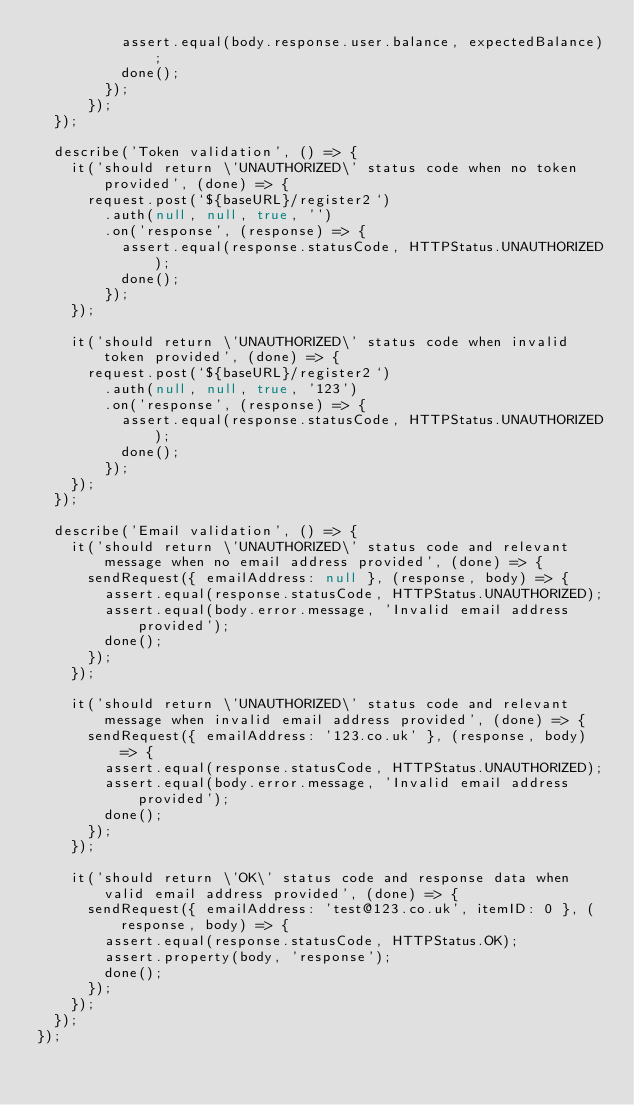<code> <loc_0><loc_0><loc_500><loc_500><_TypeScript_>          assert.equal(body.response.user.balance, expectedBalance);
          done();
        });
      });
  });

  describe('Token validation', () => {
    it('should return \'UNAUTHORIZED\' status code when no token provided', (done) => {
      request.post(`${baseURL}/register2`)
        .auth(null, null, true, '')
        .on('response', (response) => {
          assert.equal(response.statusCode, HTTPStatus.UNAUTHORIZED);
          done();
        });
    });

    it('should return \'UNAUTHORIZED\' status code when invalid token provided', (done) => {
      request.post(`${baseURL}/register2`)
        .auth(null, null, true, '123')
        .on('response', (response) => {
          assert.equal(response.statusCode, HTTPStatus.UNAUTHORIZED);
          done();
        });
    });
  });

  describe('Email validation', () => {
    it('should return \'UNAUTHORIZED\' status code and relevant message when no email address provided', (done) => {
      sendRequest({ emailAddress: null }, (response, body) => {
        assert.equal(response.statusCode, HTTPStatus.UNAUTHORIZED);
        assert.equal(body.error.message, 'Invalid email address provided');
        done();
      });
    });

    it('should return \'UNAUTHORIZED\' status code and relevant message when invalid email address provided', (done) => {
      sendRequest({ emailAddress: '123.co.uk' }, (response, body) => {
        assert.equal(response.statusCode, HTTPStatus.UNAUTHORIZED);
        assert.equal(body.error.message, 'Invalid email address provided');
        done();
      });
    });

    it('should return \'OK\' status code and response data when valid email address provided', (done) => {
      sendRequest({ emailAddress: 'test@123.co.uk', itemID: 0 }, (response, body) => {
        assert.equal(response.statusCode, HTTPStatus.OK);
        assert.property(body, 'response');
        done();
      });
    });
  });
});
</code> 